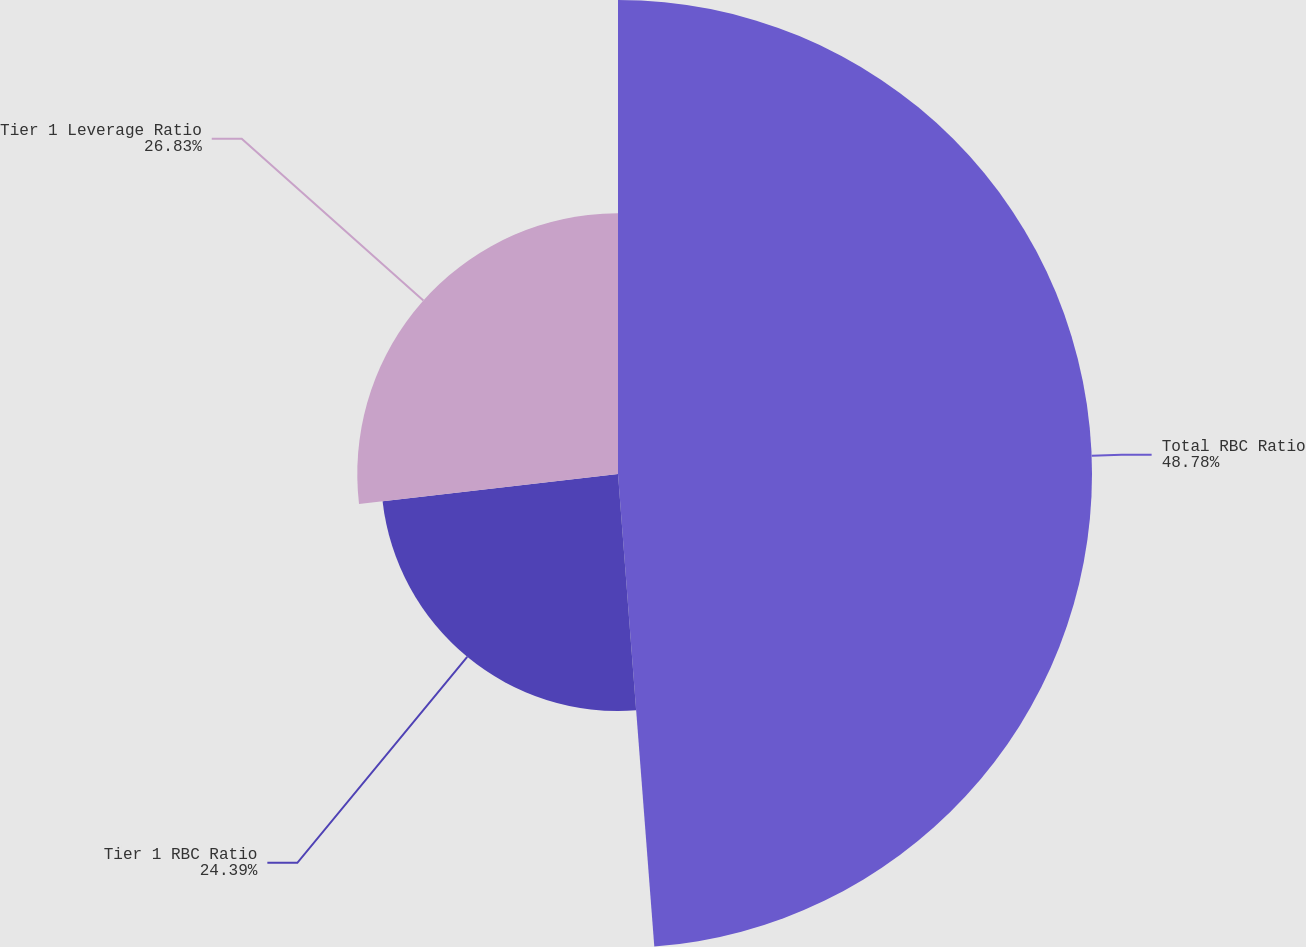<chart> <loc_0><loc_0><loc_500><loc_500><pie_chart><fcel>Total RBC Ratio<fcel>Tier 1 RBC Ratio<fcel>Tier 1 Leverage Ratio<nl><fcel>48.78%<fcel>24.39%<fcel>26.83%<nl></chart> 